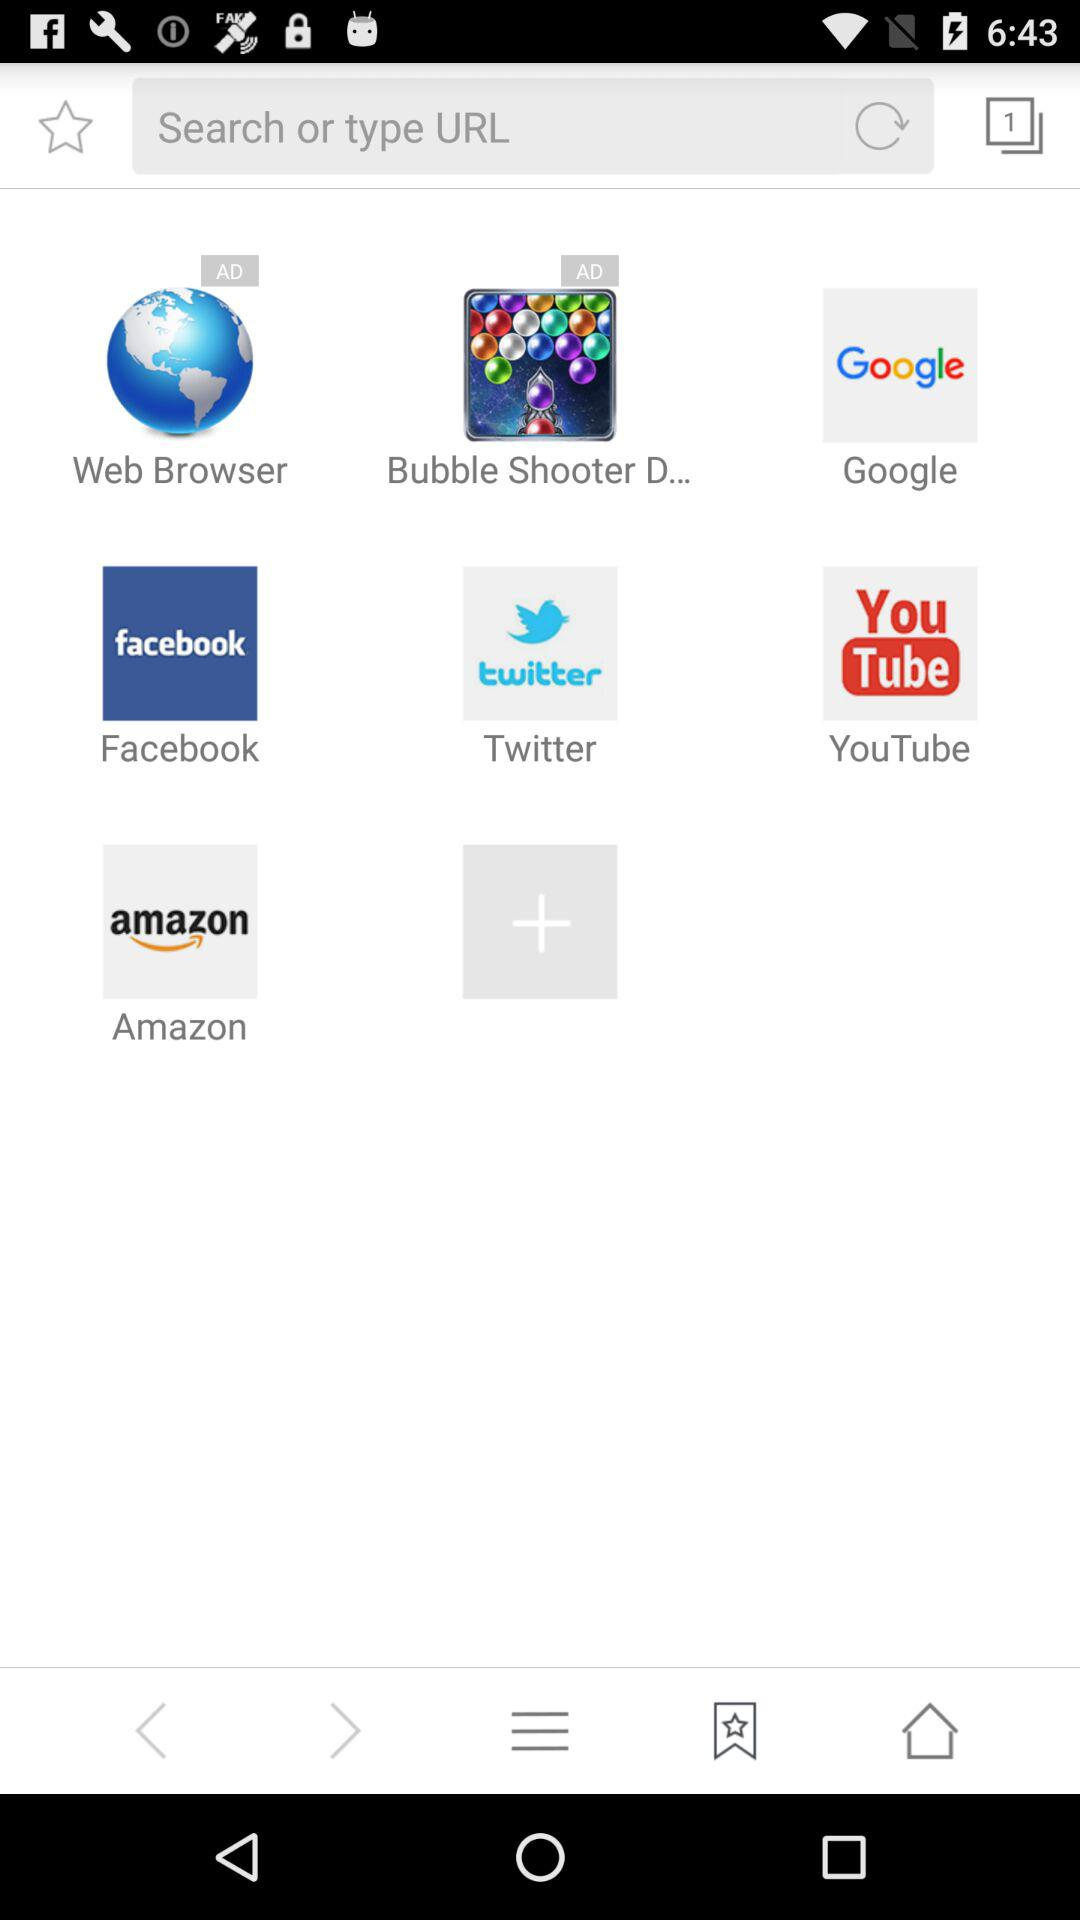What's the name of the application that contains advertisements? The names of the applications that contain advertisements are "Web Browser" and "Bubble Shooter D...". 